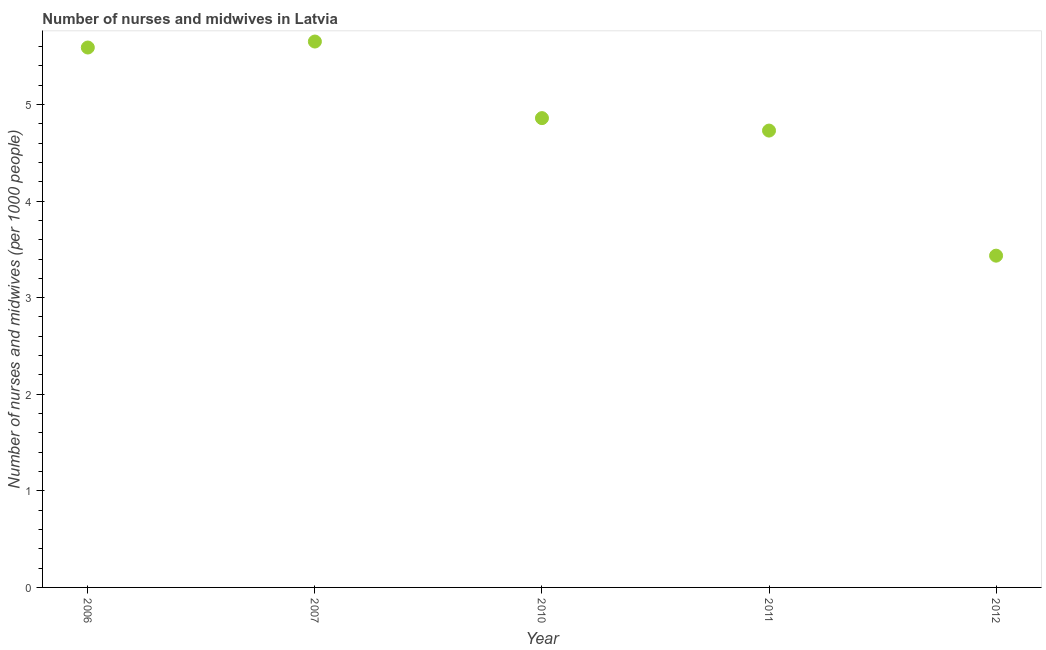What is the number of nurses and midwives in 2010?
Ensure brevity in your answer.  4.86. Across all years, what is the maximum number of nurses and midwives?
Your response must be concise. 5.65. Across all years, what is the minimum number of nurses and midwives?
Offer a very short reply. 3.44. In which year was the number of nurses and midwives minimum?
Provide a succinct answer. 2012. What is the sum of the number of nurses and midwives?
Give a very brief answer. 24.27. What is the difference between the number of nurses and midwives in 2007 and 2010?
Give a very brief answer. 0.79. What is the average number of nurses and midwives per year?
Provide a succinct answer. 4.85. What is the median number of nurses and midwives?
Your response must be concise. 4.86. In how many years, is the number of nurses and midwives greater than 5.2 ?
Ensure brevity in your answer.  2. What is the ratio of the number of nurses and midwives in 2007 to that in 2011?
Give a very brief answer. 1.19. Is the number of nurses and midwives in 2010 less than that in 2012?
Your response must be concise. No. Is the difference between the number of nurses and midwives in 2006 and 2010 greater than the difference between any two years?
Your response must be concise. No. What is the difference between the highest and the second highest number of nurses and midwives?
Provide a short and direct response. 0.06. Is the sum of the number of nurses and midwives in 2007 and 2010 greater than the maximum number of nurses and midwives across all years?
Keep it short and to the point. Yes. What is the difference between the highest and the lowest number of nurses and midwives?
Offer a very short reply. 2.22. Does the number of nurses and midwives monotonically increase over the years?
Offer a very short reply. No. How many years are there in the graph?
Provide a succinct answer. 5. What is the title of the graph?
Your answer should be compact. Number of nurses and midwives in Latvia. What is the label or title of the Y-axis?
Your answer should be very brief. Number of nurses and midwives (per 1000 people). What is the Number of nurses and midwives (per 1000 people) in 2006?
Provide a succinct answer. 5.59. What is the Number of nurses and midwives (per 1000 people) in 2007?
Ensure brevity in your answer.  5.65. What is the Number of nurses and midwives (per 1000 people) in 2010?
Keep it short and to the point. 4.86. What is the Number of nurses and midwives (per 1000 people) in 2011?
Ensure brevity in your answer.  4.73. What is the Number of nurses and midwives (per 1000 people) in 2012?
Ensure brevity in your answer.  3.44. What is the difference between the Number of nurses and midwives (per 1000 people) in 2006 and 2007?
Ensure brevity in your answer.  -0.06. What is the difference between the Number of nurses and midwives (per 1000 people) in 2006 and 2010?
Offer a very short reply. 0.73. What is the difference between the Number of nurses and midwives (per 1000 people) in 2006 and 2011?
Offer a terse response. 0.86. What is the difference between the Number of nurses and midwives (per 1000 people) in 2006 and 2012?
Make the answer very short. 2.15. What is the difference between the Number of nurses and midwives (per 1000 people) in 2007 and 2010?
Your answer should be compact. 0.79. What is the difference between the Number of nurses and midwives (per 1000 people) in 2007 and 2011?
Provide a short and direct response. 0.92. What is the difference between the Number of nurses and midwives (per 1000 people) in 2007 and 2012?
Offer a terse response. 2.22. What is the difference between the Number of nurses and midwives (per 1000 people) in 2010 and 2011?
Your answer should be compact. 0.13. What is the difference between the Number of nurses and midwives (per 1000 people) in 2010 and 2012?
Your answer should be compact. 1.42. What is the difference between the Number of nurses and midwives (per 1000 people) in 2011 and 2012?
Keep it short and to the point. 1.29. What is the ratio of the Number of nurses and midwives (per 1000 people) in 2006 to that in 2007?
Offer a very short reply. 0.99. What is the ratio of the Number of nurses and midwives (per 1000 people) in 2006 to that in 2010?
Your response must be concise. 1.15. What is the ratio of the Number of nurses and midwives (per 1000 people) in 2006 to that in 2011?
Your response must be concise. 1.18. What is the ratio of the Number of nurses and midwives (per 1000 people) in 2006 to that in 2012?
Your answer should be very brief. 1.63. What is the ratio of the Number of nurses and midwives (per 1000 people) in 2007 to that in 2010?
Ensure brevity in your answer.  1.16. What is the ratio of the Number of nurses and midwives (per 1000 people) in 2007 to that in 2011?
Your answer should be compact. 1.2. What is the ratio of the Number of nurses and midwives (per 1000 people) in 2007 to that in 2012?
Provide a short and direct response. 1.65. What is the ratio of the Number of nurses and midwives (per 1000 people) in 2010 to that in 2012?
Your answer should be compact. 1.42. What is the ratio of the Number of nurses and midwives (per 1000 people) in 2011 to that in 2012?
Give a very brief answer. 1.38. 